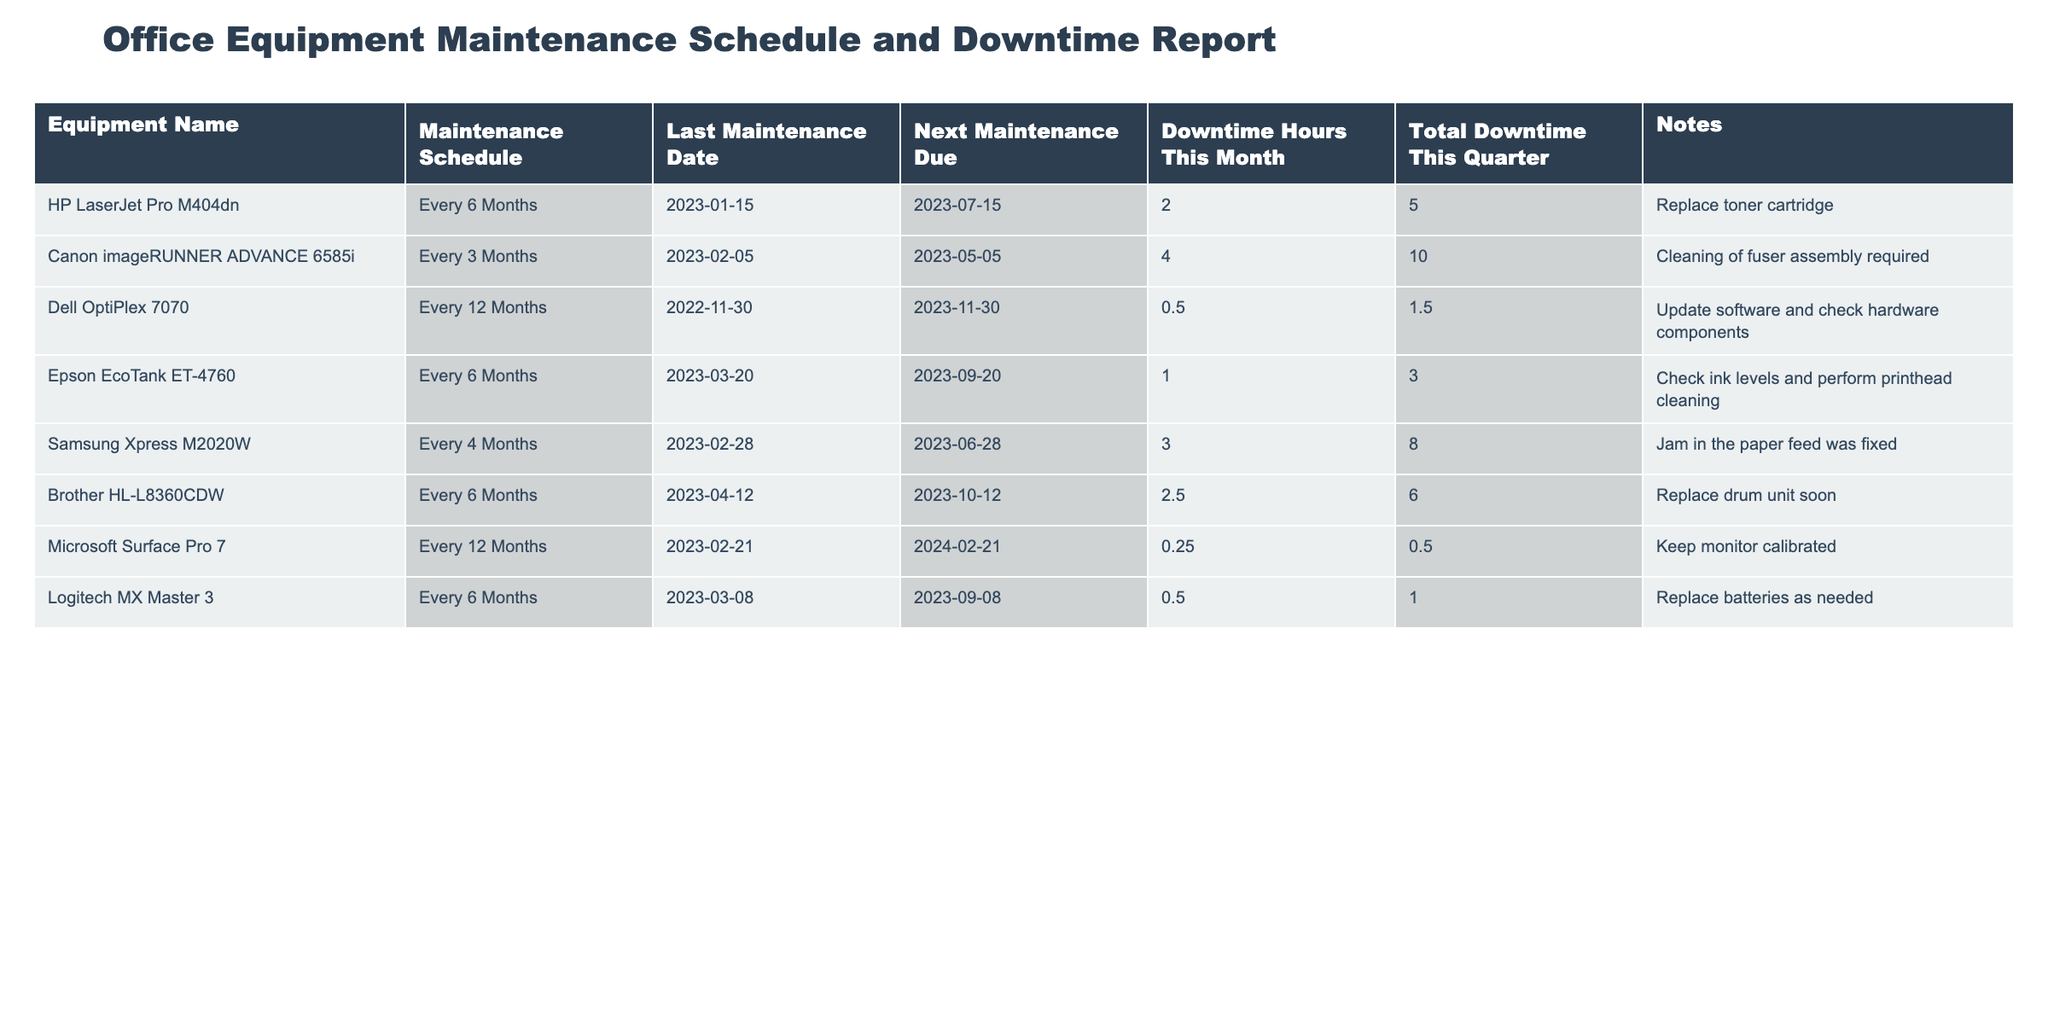What is the maintenance schedule for the Dell OptiPlex 7070? The table shows that the maintenance schedule for the Dell OptiPlex 7070 is "Every 12 Months."
Answer: Every 12 Months When is the next maintenance due for the Canon imageRUNNER ADVANCE 6585i? According to the table, the next maintenance due for the Canon imageRUNNER ADVANCE 6585i is on "2023-05-05."
Answer: 2023-05-05 How many total downtime hours have been recorded for the HP LaserJet Pro M404dn this quarter? The table states that the total downtime hours for the HP LaserJet Pro M404dn this quarter is 5 hours.
Answer: 5 hours Which equipment has the highest downtime hours this month, and how many hours? By comparing the downtime hours this month, the Samsung Xpress M2020W has the highest at 3 hours.
Answer: Samsung Xpress M2020W, 3 hours What is the difference in downtime hours this month between the Brother HL-L8360CDW and the Logitech MX Master 3? The downtime for Brother HL-L8360CDW is 2.5 hours, while for Logitech MX Master 3 it is 0.5 hours. The difference is 2.5 - 0.5 = 2 hours.
Answer: 2 hours How many pieces of equipment have a maintenance schedule of every 6 months? The table lists 4 pieces of equipment with a maintenance schedule of every 6 months: HP LaserJet Pro M404dn, Epson EcoTank ET-4760, Brother HL-L8360CDW, and Logitech MX Master 3.
Answer: 4 pieces Is the total downtime this quarter for the Canon imageRUNNER ADVANCE 6585i greater than 8 hours? The table indicates that the total downtime for Canon imageRUNNER ADVANCE 6585i is 10 hours, which is indeed greater than 8 hours.
Answer: Yes What is the average downtime this month for all equipment listed? The downtime hours this month are: 2, 4, 0.5, 1, 3, 2.5, 0.25, and 0.5. Summing these gives 13.75 hours, divided by 8 pieces of equipment gives an average of 1.71875 hours, which rounds to approximately 1.72 hours.
Answer: 1.72 hours Which equipment has the shortest maintenance interval, and what is that interval? The Canon imageRUNNER ADVANCE 6585i has the shortest maintenance interval of every 3 months.
Answer: Every 3 Months If the last maintenance date for the Samsung Xpress M2020W was fixed, when would the next maintenance be due? The table indicates that the last maintenance for Samsung Xpress M2020W was on 2023-02-28, and it is scheduled every 4 months, so the next maintenance due on 2023-06-28.
Answer: 2023-06-28 